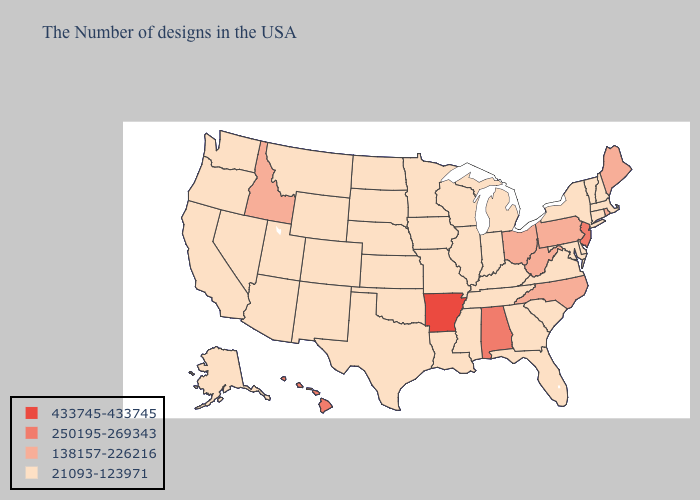Name the states that have a value in the range 21093-123971?
Keep it brief. Massachusetts, New Hampshire, Vermont, Connecticut, New York, Delaware, Maryland, Virginia, South Carolina, Florida, Georgia, Michigan, Kentucky, Indiana, Tennessee, Wisconsin, Illinois, Mississippi, Louisiana, Missouri, Minnesota, Iowa, Kansas, Nebraska, Oklahoma, Texas, South Dakota, North Dakota, Wyoming, Colorado, New Mexico, Utah, Montana, Arizona, Nevada, California, Washington, Oregon, Alaska. What is the highest value in the Northeast ?
Answer briefly. 250195-269343. What is the value of Arkansas?
Answer briefly. 433745-433745. Does New Mexico have the highest value in the West?
Quick response, please. No. Does the map have missing data?
Be succinct. No. Name the states that have a value in the range 250195-269343?
Be succinct. New Jersey, Alabama, Hawaii. Does Alaska have the lowest value in the West?
Be succinct. Yes. What is the highest value in states that border Indiana?
Short answer required. 138157-226216. Does the first symbol in the legend represent the smallest category?
Keep it brief. No. What is the lowest value in the West?
Write a very short answer. 21093-123971. Does Florida have a higher value than Maine?
Short answer required. No. Which states have the lowest value in the MidWest?
Give a very brief answer. Michigan, Indiana, Wisconsin, Illinois, Missouri, Minnesota, Iowa, Kansas, Nebraska, South Dakota, North Dakota. How many symbols are there in the legend?
Concise answer only. 4. Which states hav the highest value in the West?
Be succinct. Hawaii. 